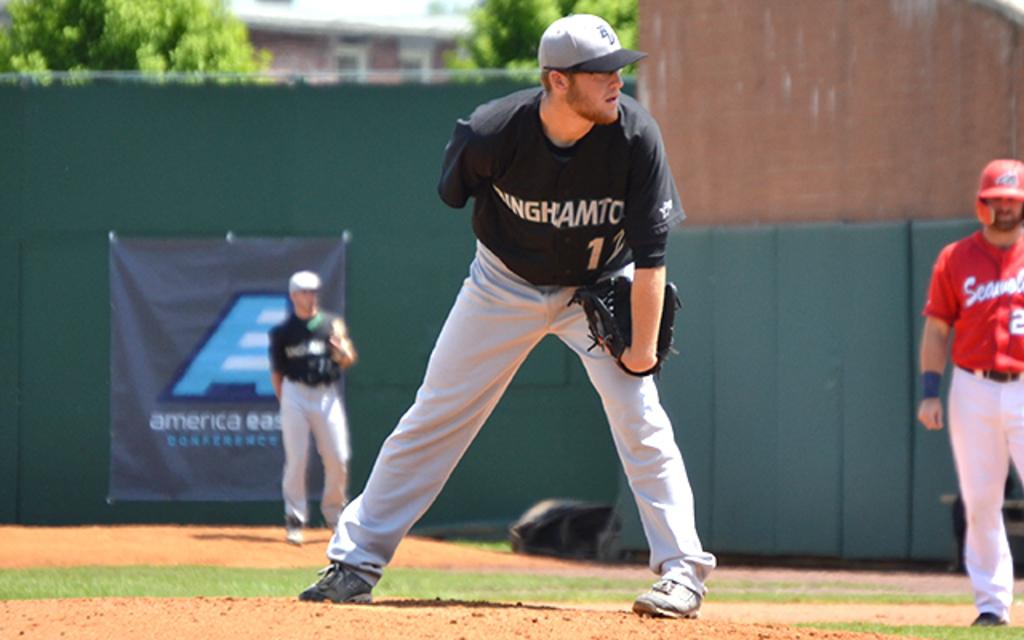What country is on the banner on the outfield wall?
Your answer should be very brief. America. What is the number of the pitcher?
Your answer should be very brief. 12. 